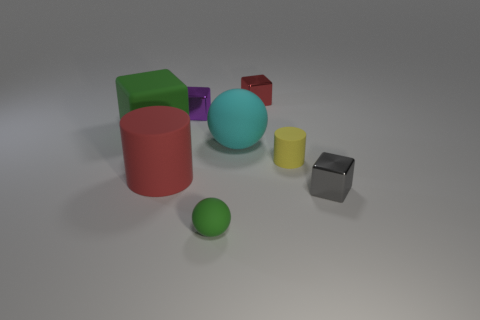Are there any yellow objects that have the same shape as the tiny green matte object?
Your answer should be very brief. No. Is the color of the large matte ball the same as the large rubber cylinder?
Provide a short and direct response. No. What material is the block that is in front of the tiny rubber object on the right side of the red metallic block made of?
Provide a succinct answer. Metal. What is the size of the gray shiny thing?
Provide a short and direct response. Small. What size is the gray thing that is made of the same material as the small purple thing?
Your answer should be very brief. Small. Is the size of the red object that is right of the red matte thing the same as the large green rubber block?
Provide a short and direct response. No. What shape is the large object right of the rubber ball that is in front of the metal cube in front of the large red cylinder?
Give a very brief answer. Sphere. What number of things are tiny rubber cylinders or big matte objects behind the red rubber thing?
Offer a very short reply. 3. There is a rubber ball behind the tiny gray block; what size is it?
Ensure brevity in your answer.  Large. There is a metal thing that is the same color as the big rubber cylinder; what shape is it?
Provide a succinct answer. Cube. 